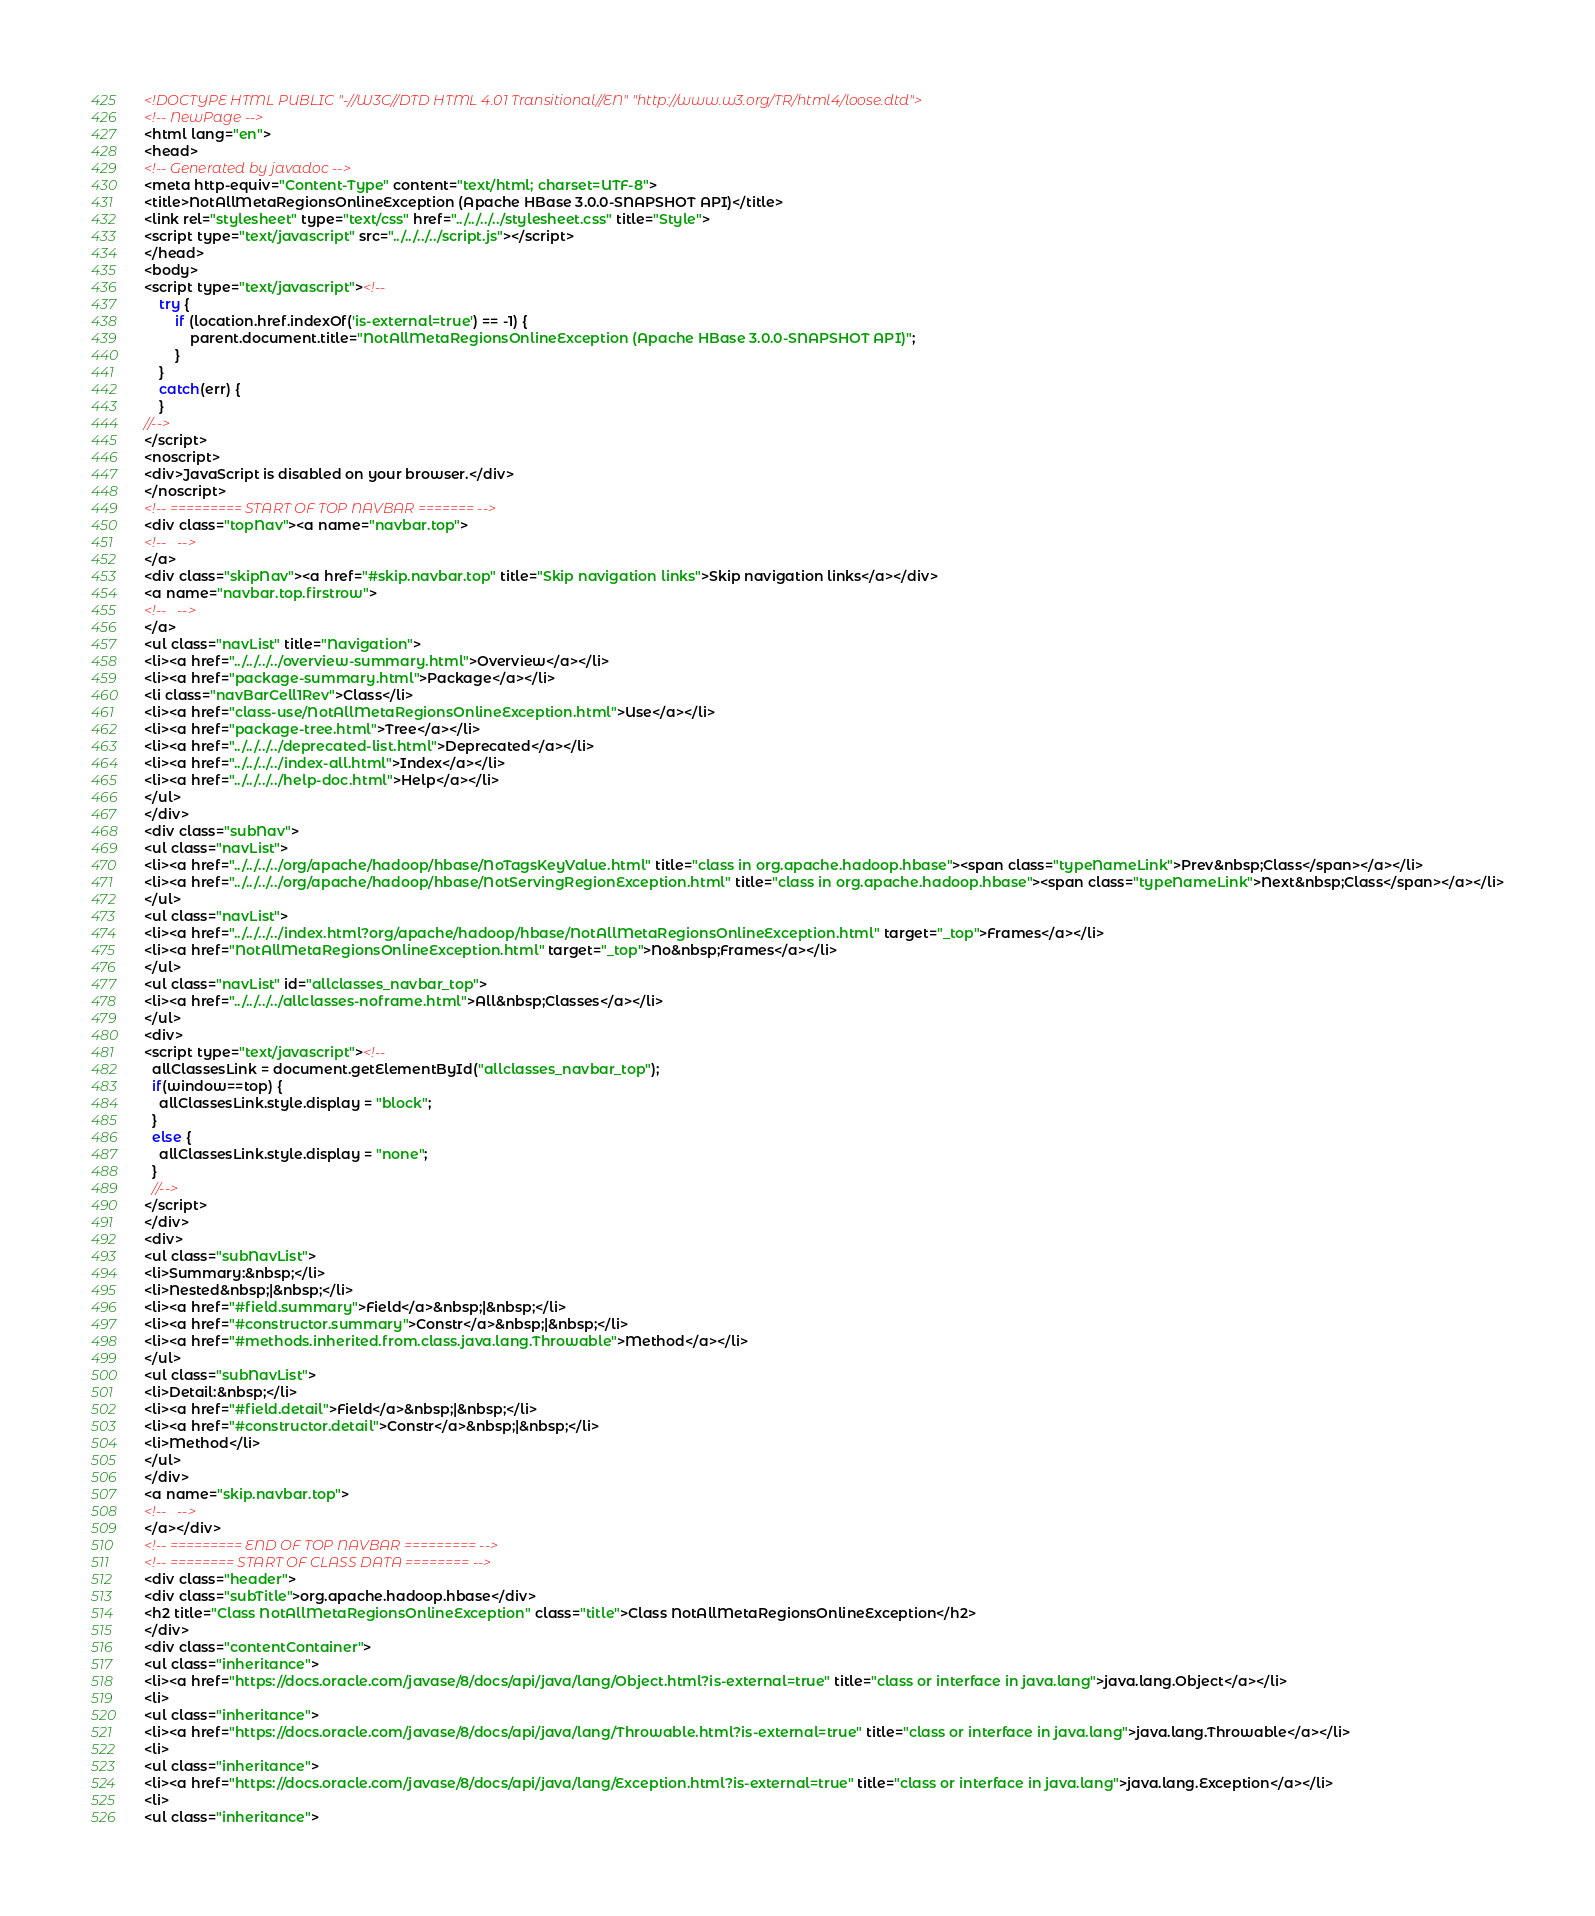<code> <loc_0><loc_0><loc_500><loc_500><_HTML_><!DOCTYPE HTML PUBLIC "-//W3C//DTD HTML 4.01 Transitional//EN" "http://www.w3.org/TR/html4/loose.dtd">
<!-- NewPage -->
<html lang="en">
<head>
<!-- Generated by javadoc -->
<meta http-equiv="Content-Type" content="text/html; charset=UTF-8">
<title>NotAllMetaRegionsOnlineException (Apache HBase 3.0.0-SNAPSHOT API)</title>
<link rel="stylesheet" type="text/css" href="../../../../stylesheet.css" title="Style">
<script type="text/javascript" src="../../../../script.js"></script>
</head>
<body>
<script type="text/javascript"><!--
    try {
        if (location.href.indexOf('is-external=true') == -1) {
            parent.document.title="NotAllMetaRegionsOnlineException (Apache HBase 3.0.0-SNAPSHOT API)";
        }
    }
    catch(err) {
    }
//-->
</script>
<noscript>
<div>JavaScript is disabled on your browser.</div>
</noscript>
<!-- ========= START OF TOP NAVBAR ======= -->
<div class="topNav"><a name="navbar.top">
<!--   -->
</a>
<div class="skipNav"><a href="#skip.navbar.top" title="Skip navigation links">Skip navigation links</a></div>
<a name="navbar.top.firstrow">
<!--   -->
</a>
<ul class="navList" title="Navigation">
<li><a href="../../../../overview-summary.html">Overview</a></li>
<li><a href="package-summary.html">Package</a></li>
<li class="navBarCell1Rev">Class</li>
<li><a href="class-use/NotAllMetaRegionsOnlineException.html">Use</a></li>
<li><a href="package-tree.html">Tree</a></li>
<li><a href="../../../../deprecated-list.html">Deprecated</a></li>
<li><a href="../../../../index-all.html">Index</a></li>
<li><a href="../../../../help-doc.html">Help</a></li>
</ul>
</div>
<div class="subNav">
<ul class="navList">
<li><a href="../../../../org/apache/hadoop/hbase/NoTagsKeyValue.html" title="class in org.apache.hadoop.hbase"><span class="typeNameLink">Prev&nbsp;Class</span></a></li>
<li><a href="../../../../org/apache/hadoop/hbase/NotServingRegionException.html" title="class in org.apache.hadoop.hbase"><span class="typeNameLink">Next&nbsp;Class</span></a></li>
</ul>
<ul class="navList">
<li><a href="../../../../index.html?org/apache/hadoop/hbase/NotAllMetaRegionsOnlineException.html" target="_top">Frames</a></li>
<li><a href="NotAllMetaRegionsOnlineException.html" target="_top">No&nbsp;Frames</a></li>
</ul>
<ul class="navList" id="allclasses_navbar_top">
<li><a href="../../../../allclasses-noframe.html">All&nbsp;Classes</a></li>
</ul>
<div>
<script type="text/javascript"><!--
  allClassesLink = document.getElementById("allclasses_navbar_top");
  if(window==top) {
    allClassesLink.style.display = "block";
  }
  else {
    allClassesLink.style.display = "none";
  }
  //-->
</script>
</div>
<div>
<ul class="subNavList">
<li>Summary:&nbsp;</li>
<li>Nested&nbsp;|&nbsp;</li>
<li><a href="#field.summary">Field</a>&nbsp;|&nbsp;</li>
<li><a href="#constructor.summary">Constr</a>&nbsp;|&nbsp;</li>
<li><a href="#methods.inherited.from.class.java.lang.Throwable">Method</a></li>
</ul>
<ul class="subNavList">
<li>Detail:&nbsp;</li>
<li><a href="#field.detail">Field</a>&nbsp;|&nbsp;</li>
<li><a href="#constructor.detail">Constr</a>&nbsp;|&nbsp;</li>
<li>Method</li>
</ul>
</div>
<a name="skip.navbar.top">
<!--   -->
</a></div>
<!-- ========= END OF TOP NAVBAR ========= -->
<!-- ======== START OF CLASS DATA ======== -->
<div class="header">
<div class="subTitle">org.apache.hadoop.hbase</div>
<h2 title="Class NotAllMetaRegionsOnlineException" class="title">Class NotAllMetaRegionsOnlineException</h2>
</div>
<div class="contentContainer">
<ul class="inheritance">
<li><a href="https://docs.oracle.com/javase/8/docs/api/java/lang/Object.html?is-external=true" title="class or interface in java.lang">java.lang.Object</a></li>
<li>
<ul class="inheritance">
<li><a href="https://docs.oracle.com/javase/8/docs/api/java/lang/Throwable.html?is-external=true" title="class or interface in java.lang">java.lang.Throwable</a></li>
<li>
<ul class="inheritance">
<li><a href="https://docs.oracle.com/javase/8/docs/api/java/lang/Exception.html?is-external=true" title="class or interface in java.lang">java.lang.Exception</a></li>
<li>
<ul class="inheritance"></code> 